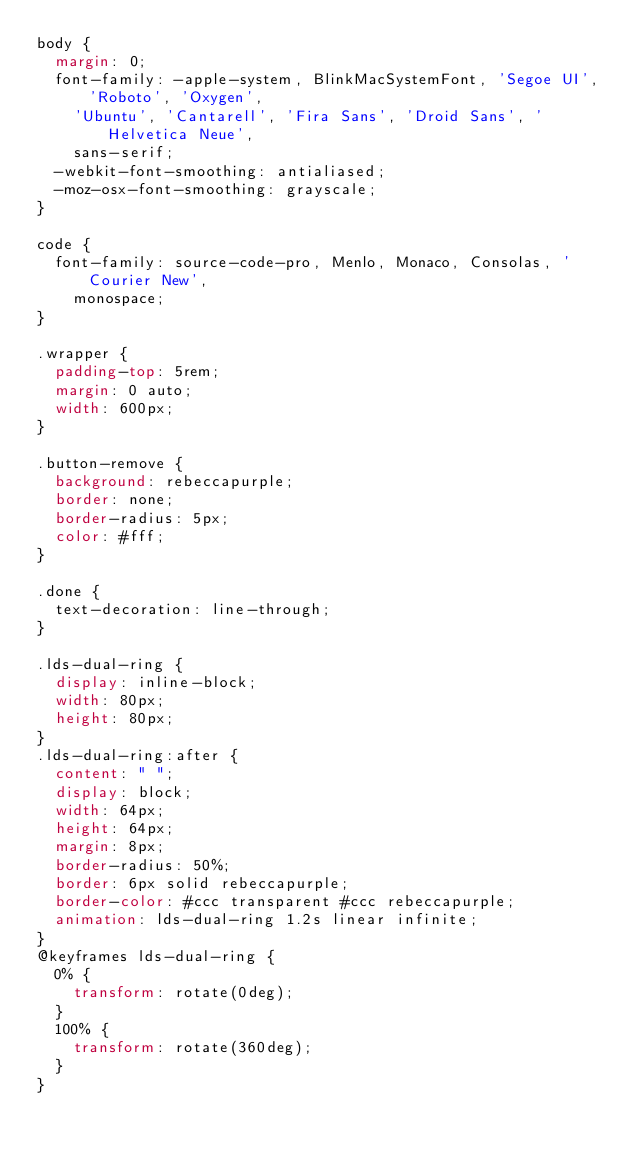Convert code to text. <code><loc_0><loc_0><loc_500><loc_500><_CSS_>body {
  margin: 0;
  font-family: -apple-system, BlinkMacSystemFont, 'Segoe UI', 'Roboto', 'Oxygen',
    'Ubuntu', 'Cantarell', 'Fira Sans', 'Droid Sans', 'Helvetica Neue',
    sans-serif;
  -webkit-font-smoothing: antialiased;
  -moz-osx-font-smoothing: grayscale;
}

code {
  font-family: source-code-pro, Menlo, Monaco, Consolas, 'Courier New',
    monospace;
}

.wrapper {
  padding-top: 5rem;
  margin: 0 auto;
  width: 600px;
}

.button-remove {
  background: rebeccapurple;
  border: none;
  border-radius: 5px;
  color: #fff;
}

.done {
  text-decoration: line-through;
}

.lds-dual-ring {
  display: inline-block;
  width: 80px;
  height: 80px;
}
.lds-dual-ring:after {
  content: " ";
  display: block;
  width: 64px;
  height: 64px;
  margin: 8px;
  border-radius: 50%;
  border: 6px solid rebeccapurple;
  border-color: #ccc transparent #ccc rebeccapurple;
  animation: lds-dual-ring 1.2s linear infinite;
}
@keyframes lds-dual-ring {
  0% {
    transform: rotate(0deg);
  }
  100% {
    transform: rotate(360deg);
  }
}</code> 